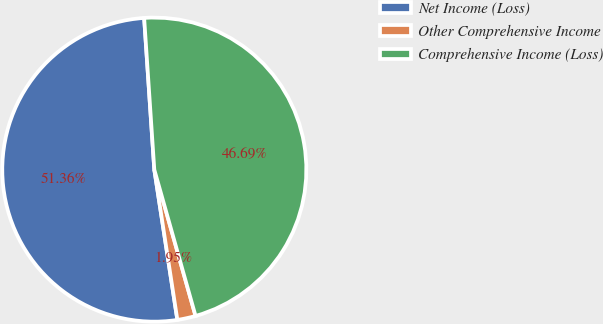Convert chart to OTSL. <chart><loc_0><loc_0><loc_500><loc_500><pie_chart><fcel>Net Income (Loss)<fcel>Other Comprehensive Income<fcel>Comprehensive Income (Loss)<nl><fcel>51.36%<fcel>1.95%<fcel>46.69%<nl></chart> 